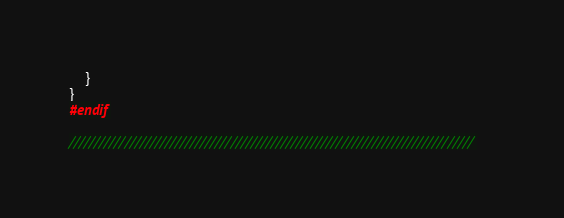<code> <loc_0><loc_0><loc_500><loc_500><_C++_>    }
}
#endif

////////////////////////////////////////////////////////////////////////////////
</code> 